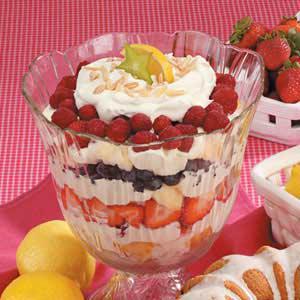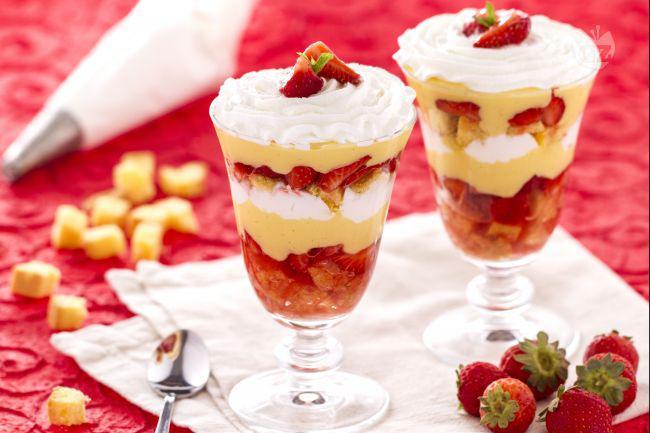The first image is the image on the left, the second image is the image on the right. Analyze the images presented: Is the assertion "An image shows a whip cream-topped dessert garnished with one red colored berries and a green leafy sprig." valid? Answer yes or no. Yes. 